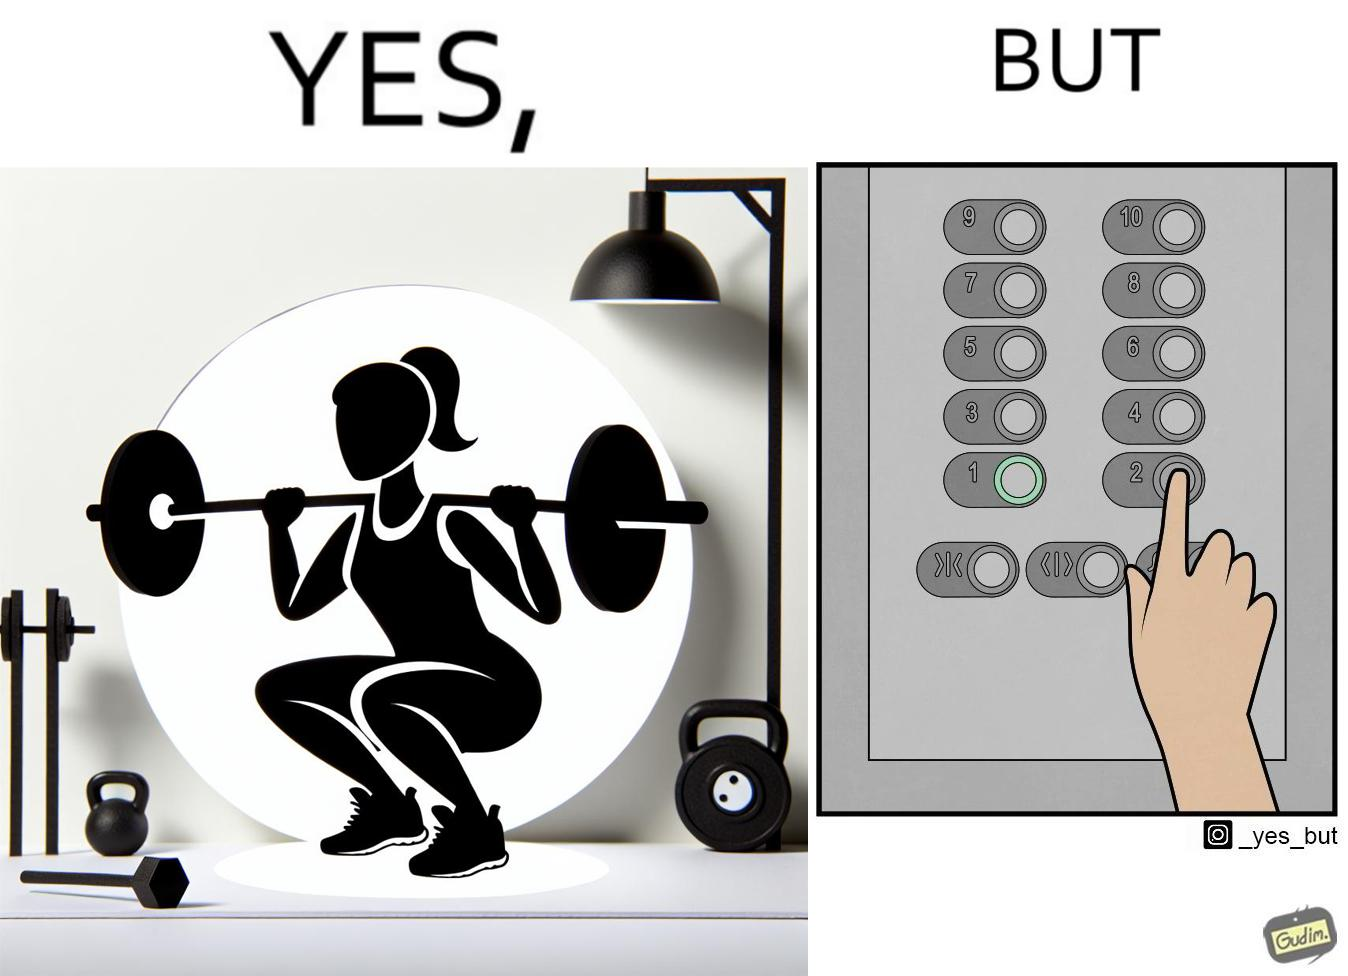Describe what you see in this image. The image is satirical because it shows that while people do various kinds of exercises and go to gym to stay fit, they avoid doing simplest of physical tasks like using stairs instead of elevators to get to even the first or the second floor of a building. 